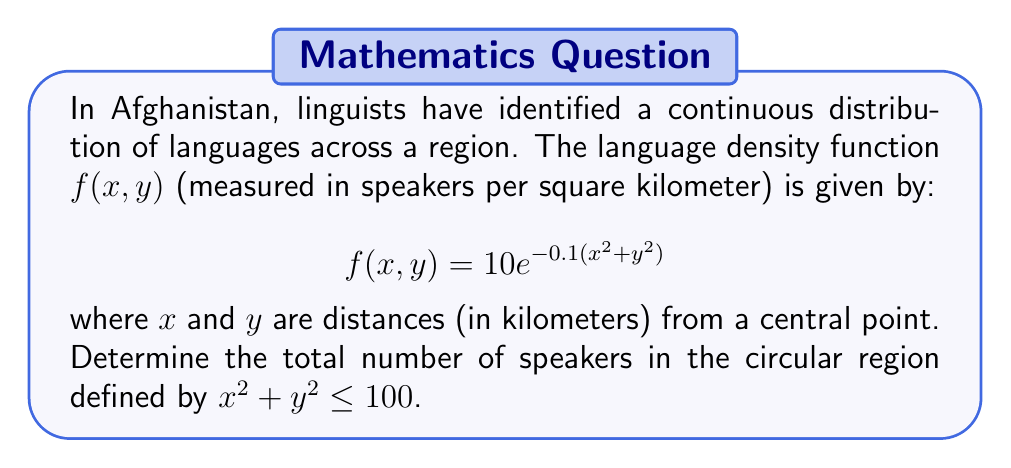Solve this math problem. To solve this problem, we need to use measure theory and integration techniques. We'll follow these steps:

1) The given region is a circle with radius 10 km (since $x^2 + y^2 \leq 100$).

2) To find the total number of speakers, we need to integrate the density function over this circular region.

3) Given the circular symmetry, it's best to use polar coordinates. We'll make the substitution:
   $x = r\cos(\theta)$
   $y = r\sin(\theta)$

4) The Jacobian for this transformation is $r$, so our integral becomes:

   $$\int_0^{2\pi} \int_0^{10} f(r\cos(\theta), r\sin(\theta)) \cdot r \, dr \, d\theta$$

5) Substituting our function:

   $$\int_0^{2\pi} \int_0^{10} 10e^{-0.1(r^2\cos^2(\theta)+r^2\sin^2(\theta))} \cdot r \, dr \, d\theta$$

6) Simplify:

   $$\int_0^{2\pi} \int_0^{10} 10e^{-0.1r^2} \cdot r \, dr \, d\theta$$

7) The inner integral doesn't depend on $\theta$, so we can separate:

   $$2\pi \int_0^{10} 10re^{-0.1r^2} \, dr$$

8) Let $u = -0.1r^2$, then $du = -0.2r \, dr$, or $dr = -5 \, du/r$:

   $$2\pi \cdot (-50) \int_{-10}^0 e^u \, du$$

9) Evaluate:

   $$2\pi \cdot (-50) [e^u]_{-10}^0 = 2\pi \cdot (-50) (1 - e^{-10})$$

10) Calculate the final result:

    $$2\pi \cdot 50 (e^{-10} - 1) \approx 987.76$$
Answer: The total number of speakers in the circular region is approximately 988 (rounded to the nearest integer). 